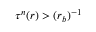<formula> <loc_0><loc_0><loc_500><loc_500>\tau ^ { n } ( r ) > ( r _ { b } ) ^ { - 1 }</formula> 